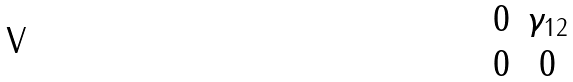<formula> <loc_0><loc_0><loc_500><loc_500>\begin{matrix} 0 & \gamma _ { 1 2 } \\ 0 & 0 \end{matrix}</formula> 